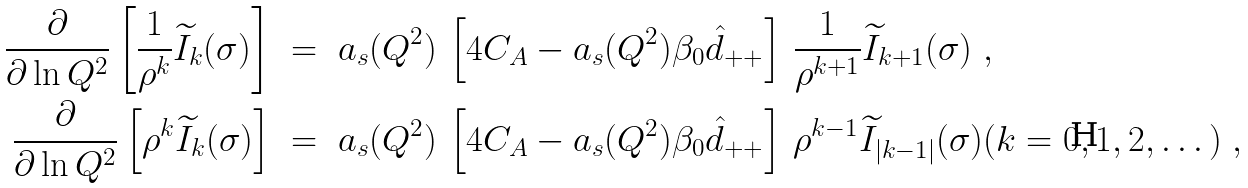Convert formula to latex. <formula><loc_0><loc_0><loc_500><loc_500>\frac { \partial } { \partial \ln Q ^ { 2 } } \left [ \frac { 1 } { \rho ^ { k } } \widetilde { I } _ { k } ( \sigma ) \right ] \ & = \ a _ { s } ( Q ^ { 2 } ) \, \left [ 4 C _ { A } - a _ { s } ( Q ^ { 2 } ) \beta _ { 0 } \hat { d } _ { + + } \right ] \, \frac { 1 } { \rho ^ { k + 1 } } \widetilde { I } _ { k + 1 } ( \sigma ) \ , \\ \frac { \partial } { \partial \ln Q ^ { 2 } } \left [ \rho ^ { k } \widetilde { I } _ { k } ( \sigma ) \right ] \ & = \ a _ { s } ( Q ^ { 2 } ) \, \left [ 4 C _ { A } - a _ { s } ( Q ^ { 2 } ) \beta _ { 0 } \hat { d } _ { + + } \right ] \, \rho ^ { k - 1 } \widetilde { I } _ { | k - 1 | } ( \sigma ) ( k = 0 , 1 , 2 , \dots ) \ ,</formula> 